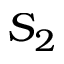<formula> <loc_0><loc_0><loc_500><loc_500>S _ { 2 }</formula> 